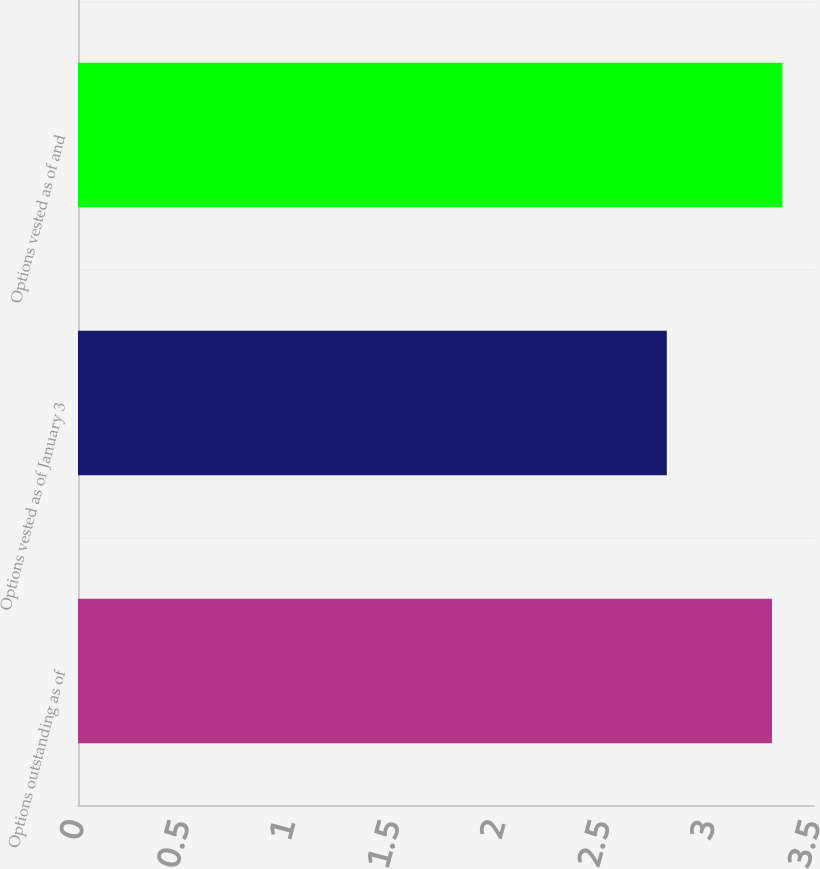Convert chart to OTSL. <chart><loc_0><loc_0><loc_500><loc_500><bar_chart><fcel>Options outstanding as of<fcel>Options vested as of January 3<fcel>Options vested as of and<nl><fcel>3.3<fcel>2.8<fcel>3.35<nl></chart> 